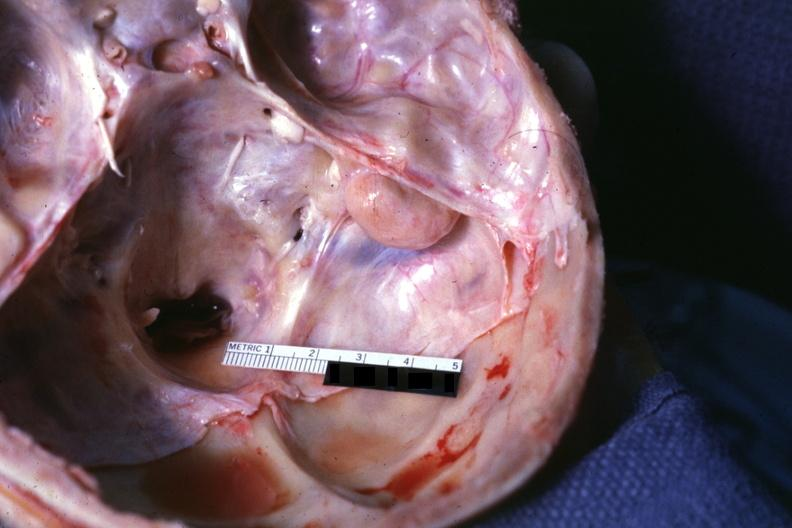s fibrous meningioma present?
Answer the question using a single word or phrase. Yes 